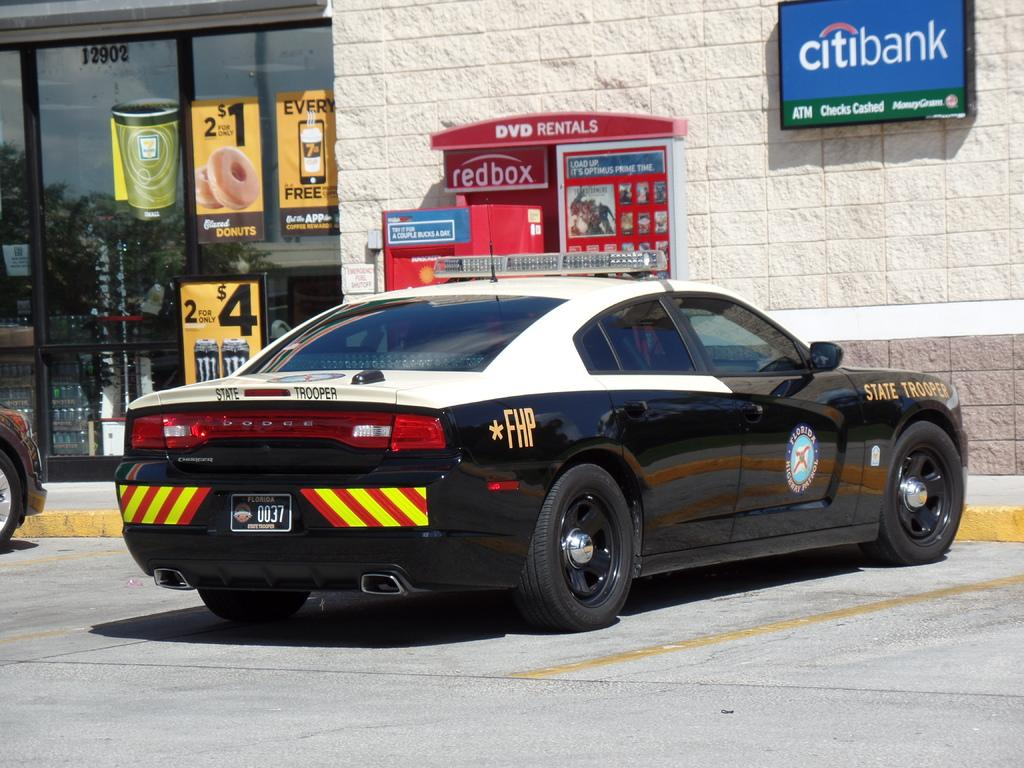What can be seen on the path in the image? There are two vehicles on the path in the image. What is on the wall in the image? There are boards on the wall in the image. What is on the glass in the image? There are posts on the glass in the image. What numbers are visible in the image? There are numbers visible in the image. What is inside the building in the image? There are objects present in the building in the image. What is the desire of the fact in the image? There is no desire or fact present in the image; it is a scene with vehicles, boards, posts, numbers, and objects. What is the surprise in the image? There is no surprise depicted in the image; it is a straightforward scene with the mentioned elements. 